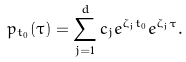<formula> <loc_0><loc_0><loc_500><loc_500>p _ { t _ { 0 } } ( \tau ) = \sum _ { j = 1 } ^ { d } c _ { j } e ^ { \zeta _ { j } t _ { 0 } } e ^ { \zeta _ { j } \tau } .</formula> 